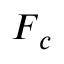<formula> <loc_0><loc_0><loc_500><loc_500>F _ { c }</formula> 